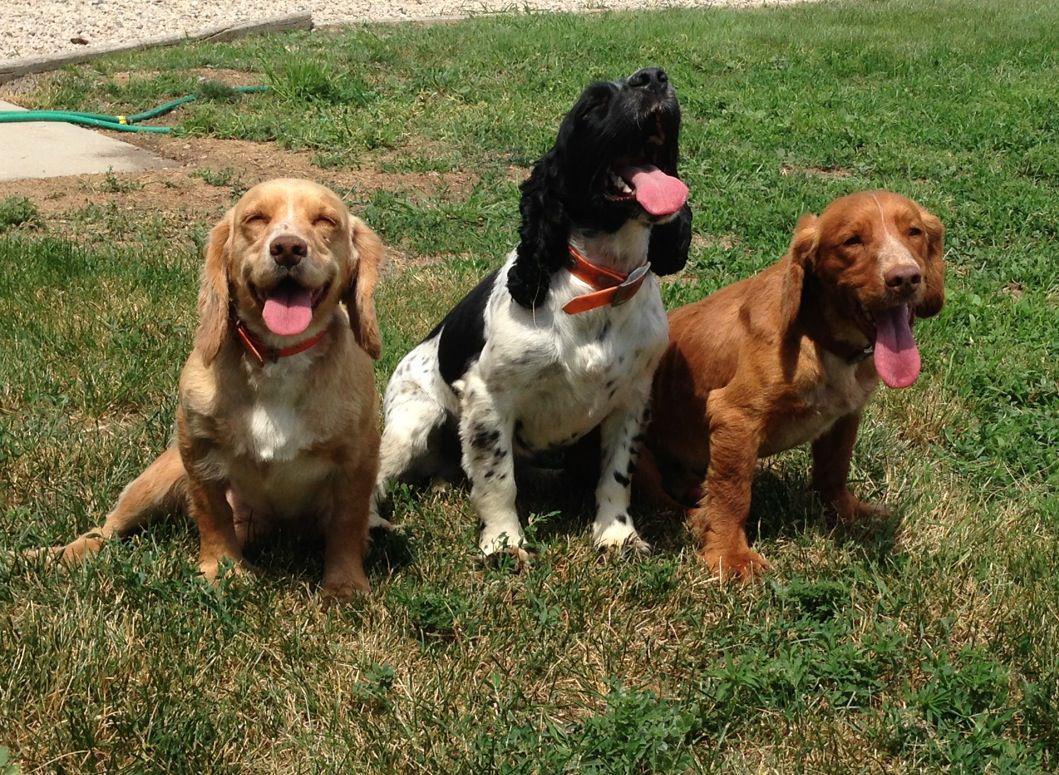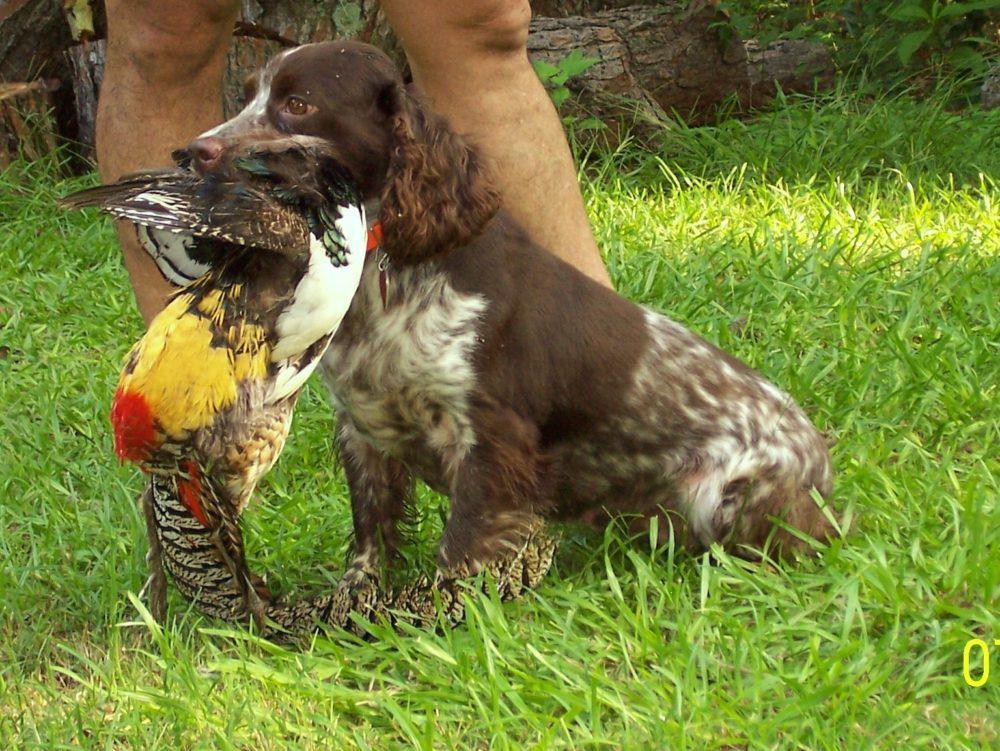The first image is the image on the left, the second image is the image on the right. Considering the images on both sides, is "The combined images include a left-facing spaniel with something large held in its mouth, and a trio of three dogs sitting together in the grass." valid? Answer yes or no. Yes. The first image is the image on the left, the second image is the image on the right. Examine the images to the left and right. Is the description "there are two dogs in the image pair" accurate? Answer yes or no. No. 